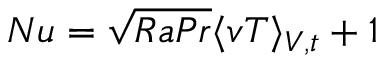Convert formula to latex. <formula><loc_0><loc_0><loc_500><loc_500>N u = \sqrt { R a P r } \langle v T \rangle _ { V , t } + 1</formula> 